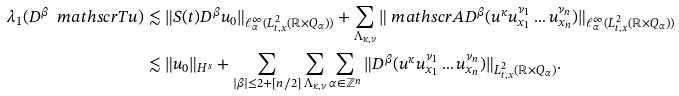<formula> <loc_0><loc_0><loc_500><loc_500>\lambda _ { 1 } ( D ^ { \beta } \ m a t h s c r { T } u ) & \lesssim \| S ( t ) D ^ { \beta } u _ { 0 } \| _ { \ell ^ { \infty } _ { \alpha } ( L ^ { 2 } _ { t , x } ( \mathbb { R } \times Q _ { \alpha } ) ) } + \sum _ { \Lambda _ { \kappa , \nu } } \| \ m a t h s c r { A } D ^ { \beta } ( u ^ { \kappa } u ^ { \nu _ { 1 } } _ { x _ { 1 } } \dots u ^ { \nu _ { n } } _ { x _ { n } } ) \| _ { \ell ^ { \infty } _ { \alpha } ( L ^ { 2 } _ { t , x } ( \mathbb { R } \times Q _ { \alpha } ) ) } \\ & \lesssim \| u _ { 0 } \| _ { H ^ { s } } + \sum _ { | \beta | \leq 2 + [ n / 2 ] } \sum _ { \Lambda _ { \kappa , \nu } } \sum _ { \alpha \in \mathbb { Z } ^ { n } } \| D ^ { \beta } ( u ^ { \kappa } u ^ { \nu _ { 1 } } _ { x _ { 1 } } \dots u ^ { \nu _ { n } } _ { x _ { n } } ) \| _ { L ^ { 2 } _ { t , x } ( \mathbb { R } \times Q _ { \alpha } ) } .</formula> 